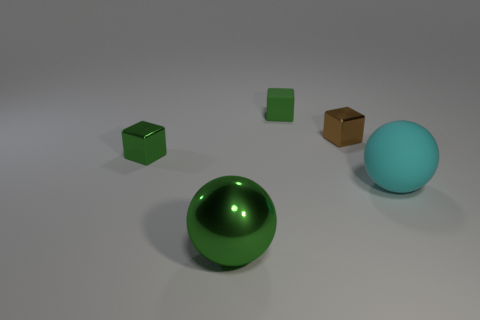There is a ball on the right side of the brown metallic thing; how big is it?
Offer a terse response. Large. Does the tiny brown cube have the same material as the large cyan thing?
Offer a terse response. No. There is a green block on the right side of the green metallic thing that is in front of the green metallic cube; is there a metallic cube to the right of it?
Make the answer very short. Yes. The tiny rubber thing is what color?
Your answer should be compact. Green. There is a thing that is the same size as the rubber ball; what color is it?
Give a very brief answer. Green. Is the shape of the matte thing that is to the left of the large matte object the same as  the small green metal thing?
Give a very brief answer. Yes. The small thing that is to the left of the green shiny object that is on the right side of the block that is in front of the tiny brown metallic block is what color?
Offer a terse response. Green. Are any purple matte cubes visible?
Offer a terse response. No. How many other objects are there of the same size as the brown metallic block?
Make the answer very short. 2. There is a tiny matte thing; is its color the same as the small metallic block that is in front of the small brown thing?
Make the answer very short. Yes. 